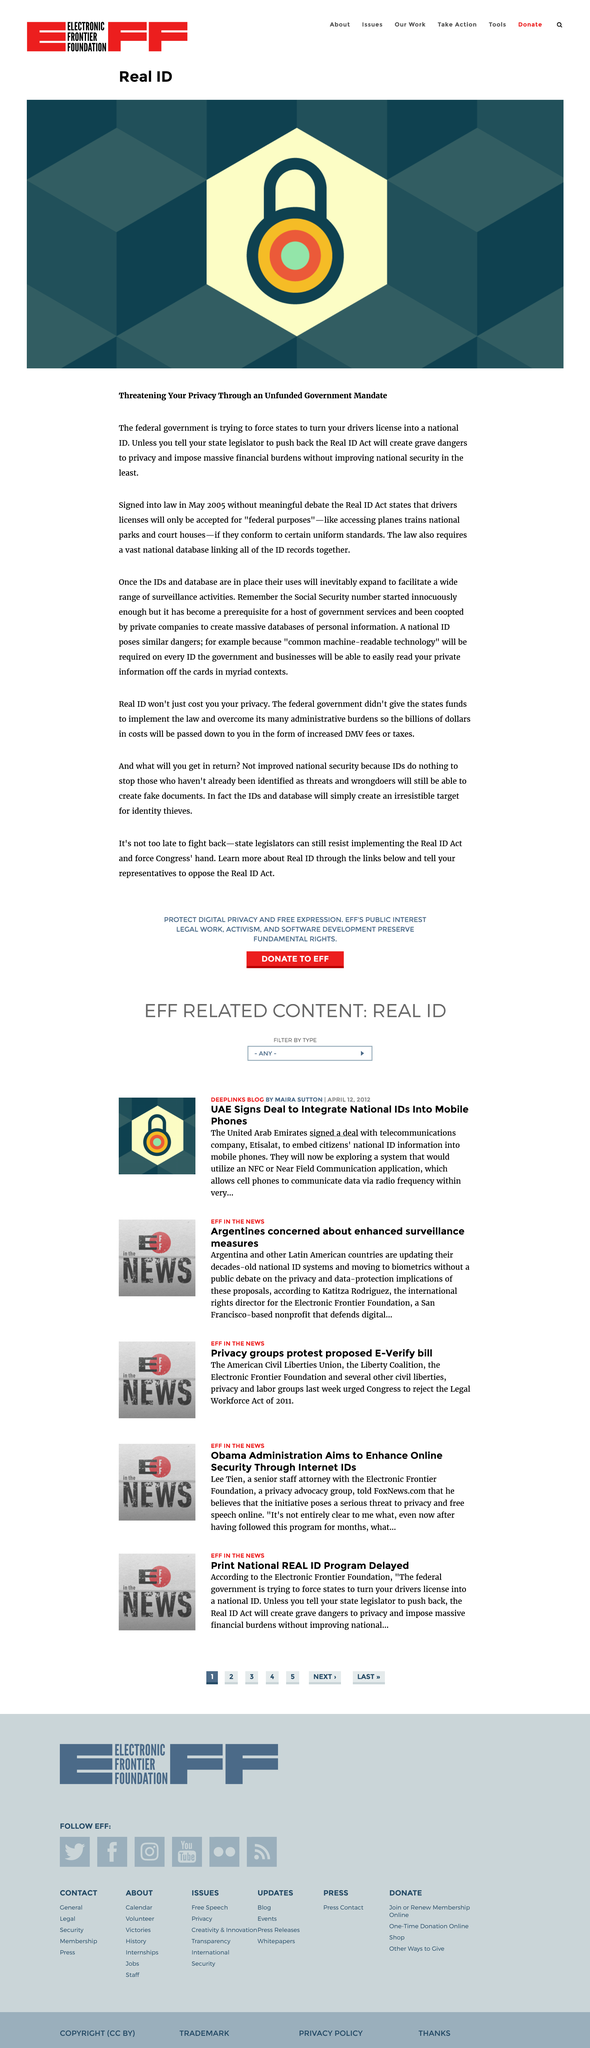Mention a couple of crucial points in this snapshot. The Real ID Act was signed in May 2005. The Real ID Act seeks to mandate that states transform their driver licenses into a national identification document, thereby standardizing the issuance of licenses and increasing the security of personal information. The Real ID Act poses a significant threat to the privacy of individuals, as it allows for the collection and sharing of personal information without adequate safeguards in place to protect against misuse and abuse. 